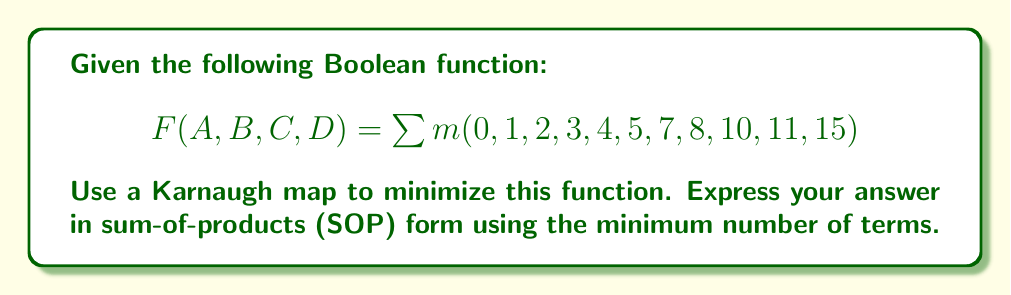Can you answer this question? 1. First, let's create a 4-variable Karnaugh map:

[asy]
unitsize(1cm);
draw((0,0)--(4,0)--(4,4)--(0,4)--cycle);
draw((0,2)--(4,2));
draw((2,0)--(2,4));
label("00", (1,4.5));
label("01", (3,4.5));
label("11", (3,-0.5));
label("10", (1,-0.5));
label("00", (-0.5,3));
label("01", (-0.5,1));
label("11", (4.5,1));
label("10", (4.5,3));
label("AB", (-1,2));
label("CD", (2,5));
label("1", (0.5,3.5));
label("1", (1.5,3.5));
label("1", (0.5,2.5));
label("1", (1.5,2.5));
label("1", (0.5,1.5));
label("1", (0.5,0.5));
label("1", (1.5,0.5));
label("1", (2.5,3.5));
label("1", (3.5,2.5));
label("1", (2.5,0.5));
label("1", (3.5,0.5));
[/asy]

2. Now, we look for the largest possible groups of 1s:

   a) There's a group of 4 in the top-left corner: $\overline{A}\overline{B}$
   b) There's a group of 4 that wraps around the left side: $\overline{A}\overline{D}$
   c) There's a group of 2 in the bottom-right corner: $ABD$

3. These groups cover all the 1s in the Karnaugh map with the minimum number of terms.

4. We can now write our minimized function in SOP form by ORing these terms together:

   $F(A,B,C,D) = \overline{A}\overline{B} + \overline{A}\overline{D} + ABD$

5. This expression uses only 3 terms and cannot be further simplified.
Answer: $\overline{A}\overline{B} + \overline{A}\overline{D} + ABD$ 